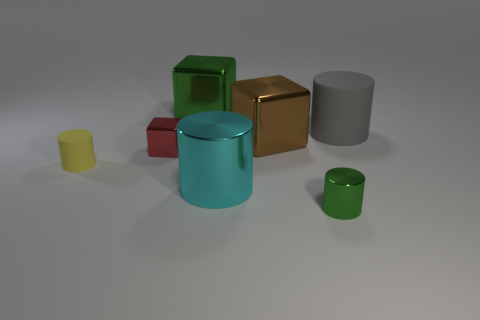Subtract all green shiny cylinders. How many cylinders are left? 3 Subtract all green cylinders. How many cylinders are left? 3 Add 3 large blue metallic cylinders. How many objects exist? 10 Subtract 1 cubes. How many cubes are left? 2 Subtract all cylinders. How many objects are left? 3 Subtract all red cylinders. Subtract all blue blocks. How many cylinders are left? 4 Add 4 tiny yellow things. How many tiny yellow things exist? 5 Subtract 0 red cylinders. How many objects are left? 7 Subtract all brown things. Subtract all green blocks. How many objects are left? 5 Add 4 cyan things. How many cyan things are left? 5 